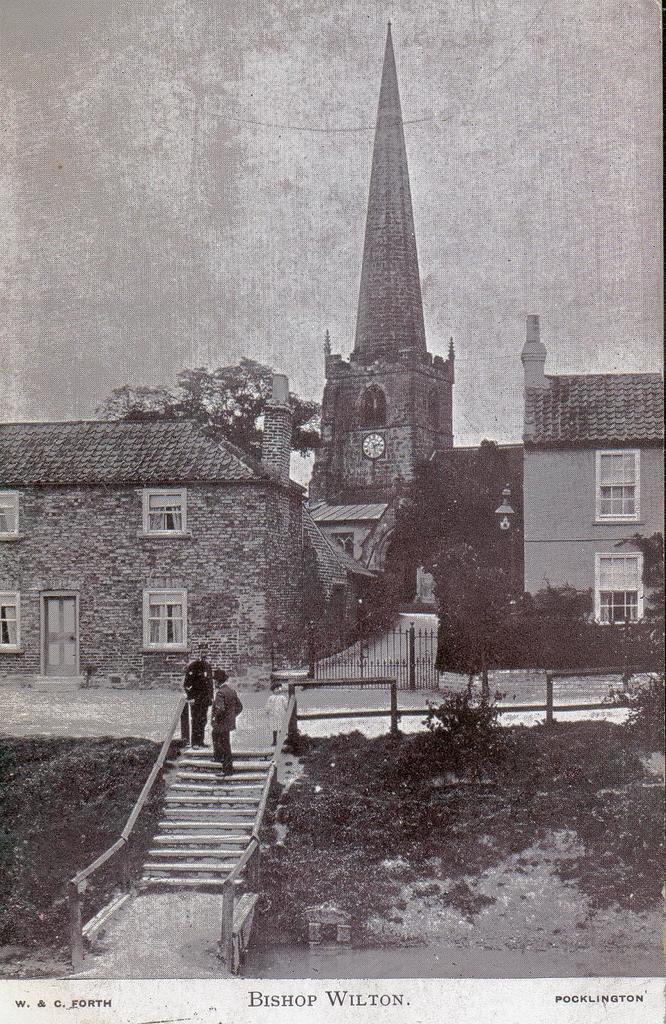How would you summarize this image in a sentence or two? In the image I can see a place where we have some buildings, staircase on which there are some people and also I can see some trees and plants. 